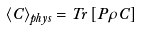Convert formula to latex. <formula><loc_0><loc_0><loc_500><loc_500>\left \langle C \right \rangle _ { p h y s } = T r \left [ P \rho C \right ]</formula> 